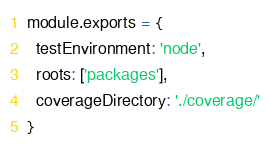Convert code to text. <code><loc_0><loc_0><loc_500><loc_500><_JavaScript_>module.exports = {
  testEnvironment: 'node',
  roots: ['packages'],
  coverageDirectory: './coverage/'
}
</code> 